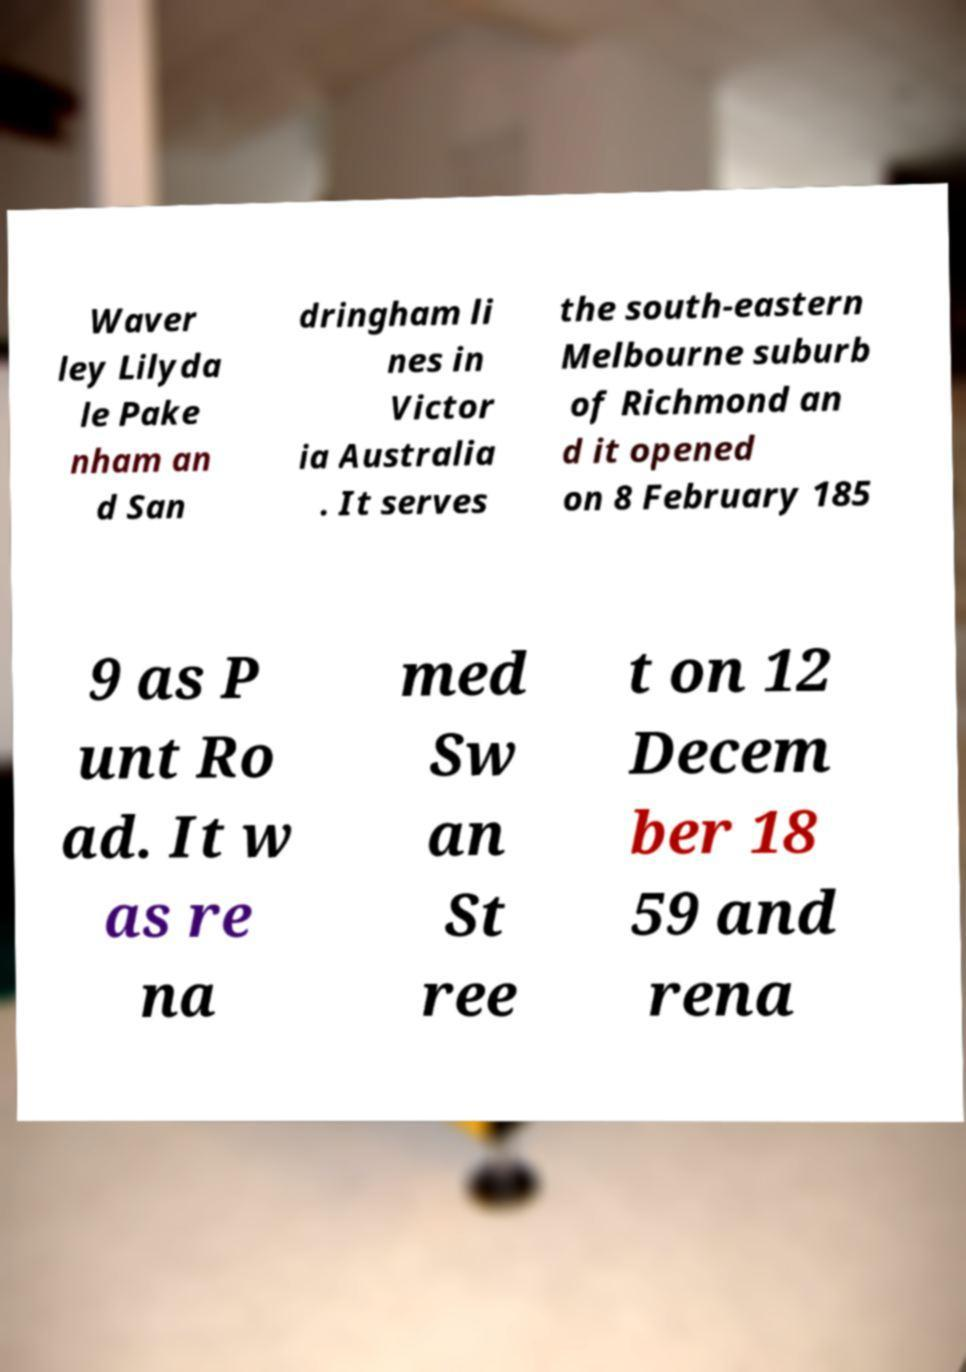What messages or text are displayed in this image? I need them in a readable, typed format. Waver ley Lilyda le Pake nham an d San dringham li nes in Victor ia Australia . It serves the south-eastern Melbourne suburb of Richmond an d it opened on 8 February 185 9 as P unt Ro ad. It w as re na med Sw an St ree t on 12 Decem ber 18 59 and rena 